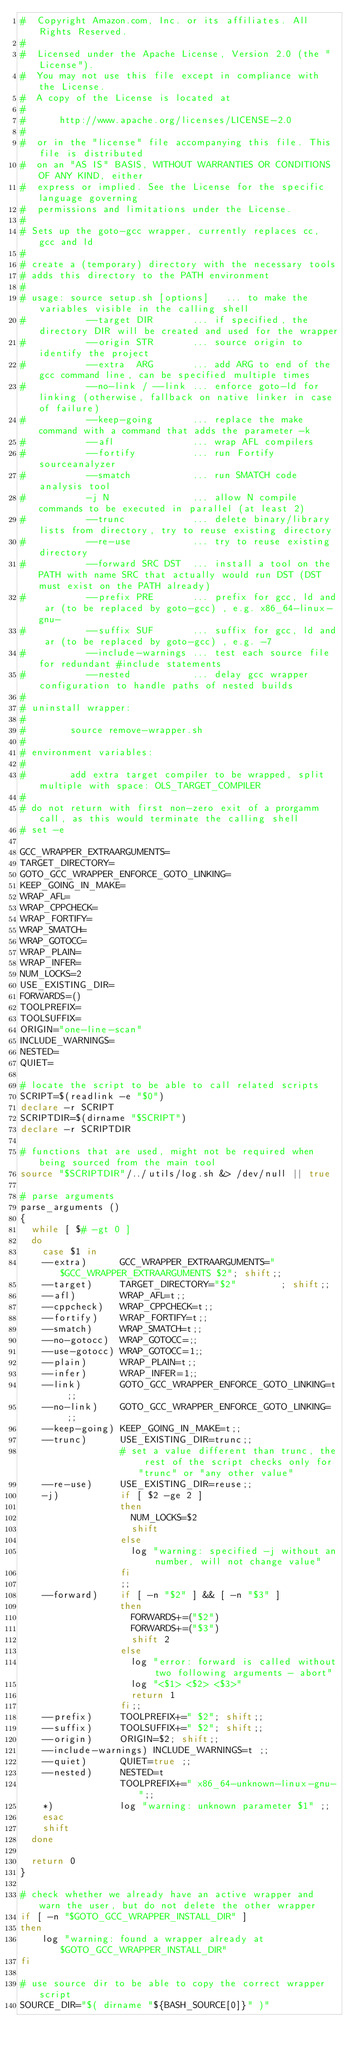Convert code to text. <code><loc_0><loc_0><loc_500><loc_500><_Bash_>#  Copyright Amazon.com, Inc. or its affiliates. All Rights Reserved.
#  
#  Licensed under the Apache License, Version 2.0 (the "License").
#  You may not use this file except in compliance with the License.
#  A copy of the License is located at
#  
#      http://www.apache.org/licenses/LICENSE-2.0
#  
#  or in the "license" file accompanying this file. This file is distributed 
#  on an "AS IS" BASIS, WITHOUT WARRANTIES OR CONDITIONS OF ANY KIND, either 
#  express or implied. See the License for the specific language governing 
#  permissions and limitations under the License.
#
# Sets up the goto-gcc wrapper, currently replaces cc, gcc and ld
#
# create a (temporary) directory with the necessary tools
# adds this directory to the PATH environment
#
# usage: source setup.sh [options]   ... to make the variables visible in the calling shell
#           --target DIR       ... if specified, the directory DIR will be created and used for the wrapper
#           --origin STR       ... source origin to identify the project
#           --extra  ARG       ... add ARG to end of the gcc command line, can be specified multiple times
#           --no-link / --link ... enforce goto-ld for linking (otherwise, fallback on native linker in case of failure)
#           --keep-going       ... replace the make command with a command that adds the parameter -k
#           --afl              ... wrap AFL compilers
#           --fortify          ... run Fortify sourceanalyzer
#           --smatch           ... run SMATCH code analysis tool
#           -j N               ... allow N compile commands to be executed in parallel (at least 2)
#           --trunc            ... delete binary/library lists from directory, try to reuse existing directory
#           --re-use           ... try to reuse existing directory
#           --forward SRC DST  ... install a tool on the PATH with name SRC that actually would run DST (DST must exist on the PATH already)
#           --prefix PRE       ... prefix for gcc, ld and ar (to be replaced by goto-gcc) , e.g. x86_64-linux-gnu-
#           --suffix SUF       ... suffix for gcc, ld and ar (to be replaced by goto-gcc) , e.g. -7
#           --include-warnings ... test each source file for redundant #include statements
#           --nested           ... delay gcc wrapper configuration to handle paths of nested builds
#
# uninstall wrapper:
#
#        source remove-wrapper.sh
#
# environment variables:
#
#        add extra target compiler to be wrapped, split multiple with space: OLS_TARGET_COMPILER
#
# do not return with first non-zero exit of a prorgamm call, as this would terminate the calling shell
# set -e

GCC_WRAPPER_EXTRAARGUMENTS=
TARGET_DIRECTORY=
GOTO_GCC_WRAPPER_ENFORCE_GOTO_LINKING=
KEEP_GOING_IN_MAKE=
WRAP_AFL=
WRAP_CPPCHECK=
WRAP_FORTIFY=
WRAP_SMATCH=
WRAP_GOTOCC=
WRAP_PLAIN=
WRAP_INFER=
NUM_LOCKS=2
USE_EXISTING_DIR=
FORWARDS=()
TOOLPREFIX=
TOOLSUFFIX=
ORIGIN="one-line-scan"
INCLUDE_WARNINGS=
NESTED=
QUIET=

# locate the script to be able to call related scripts
SCRIPT=$(readlink -e "$0")
declare -r SCRIPT
SCRIPTDIR=$(dirname "$SCRIPT")
declare -r SCRIPTDIR

# functions that are used, might not be required when being sourced from the main tool
source "$SCRIPTDIR"/../utils/log.sh &> /dev/null || true

# parse arguments
parse_arguments ()
{
  while [ $# -gt 0 ]
  do
    case $1 in
    --extra)      GCC_WRAPPER_EXTRAARGUMENTS="$GCC_WRAPPER_EXTRAARGUMENTS $2"; shift;;
    --target)     TARGET_DIRECTORY="$2"        ; shift;;
    --afl)        WRAP_AFL=t;;
    --cppcheck)   WRAP_CPPCHECK=t;;
    --fortify)    WRAP_FORTIFY=t;;
    --smatch)     WRAP_SMATCH=t;;
    --no-gotocc)  WRAP_GOTOCC=;;
    --use-gotocc) WRAP_GOTOCC=1;;
    --plain)      WRAP_PLAIN=t;;
    --infer)      WRAP_INFER=1;;
    --link)       GOTO_GCC_WRAPPER_ENFORCE_GOTO_LINKING=t ;;
    --no-link)    GOTO_GCC_WRAPPER_ENFORCE_GOTO_LINKING=  ;;
    --keep-going) KEEP_GOING_IN_MAKE=t;;
    --trunc)      USE_EXISTING_DIR=trunc;;
                  # set a value different than trunc, the rest of the script checks only for "trunc" or "any other value"
    --re-use)     USE_EXISTING_DIR=reuse;;
    -j)           if [ $2 -ge 2 ]
                  then
                    NUM_LOCKS=$2
                    shift
                  else
                    log "warning: specified -j without an number, will not change value"
                  fi
                  ;;
    --forward)    if [ -n "$2" ] && [ -n "$3" ]
                  then
                    FORWARDS+=("$2")
                    FORWARDS+=("$3")
                    shift 2
                  else
                    log "error: forward is called without two following arguments - abort"
                    log "<$1> <$2> <$3>"
                    return 1
                  fi;;
    --prefix)     TOOLPREFIX+=" $2"; shift;;
    --suffix)     TOOLSUFFIX+=" $2"; shift;;
    --origin)     ORIGIN=$2; shift;;
    --include-warnings) INCLUDE_WARNINGS=t ;;
    --quiet)      QUIET=true ;;
    --nested)     NESTED=t
                  TOOLPREFIX+=" x86_64-unknown-linux-gnu-";;
    *)            log "warning: unknown parameter $1" ;;
    esac
    shift
  done

  return 0
}

# check whether we already have an active wrapper and warn the user, but do not delete the other wrapper
if [ -n "$GOTO_GCC_WRAPPER_INSTALL_DIR" ]
then
    log "warning: found a wrapper already at $GOTO_GCC_WRAPPER_INSTALL_DIR"
fi

# use source dir to be able to copy the correct wrapper script
SOURCE_DIR="$( dirname "${BASH_SOURCE[0]}" )"
</code> 